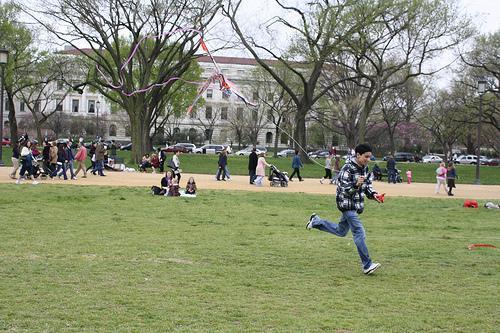How many people are flying a kite?
Give a very brief answer. 1. 